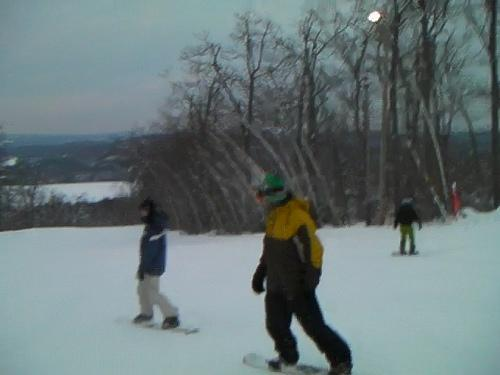What does the white light come from? sun 